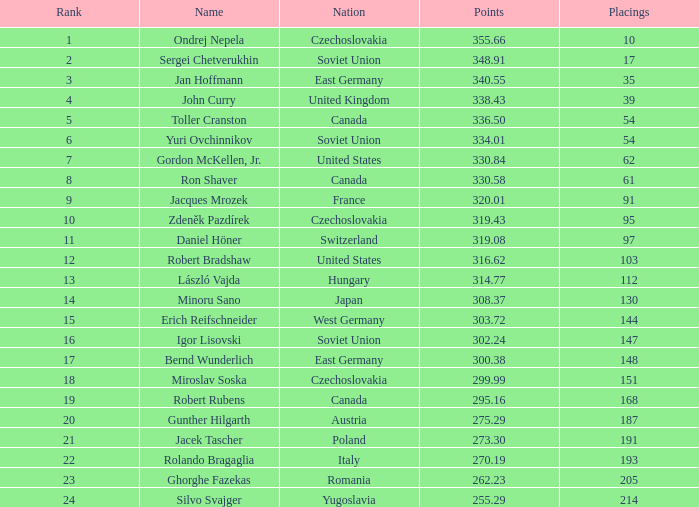What is the number of placings with points below 330.84 and a name of silvo svajger? 1.0. 